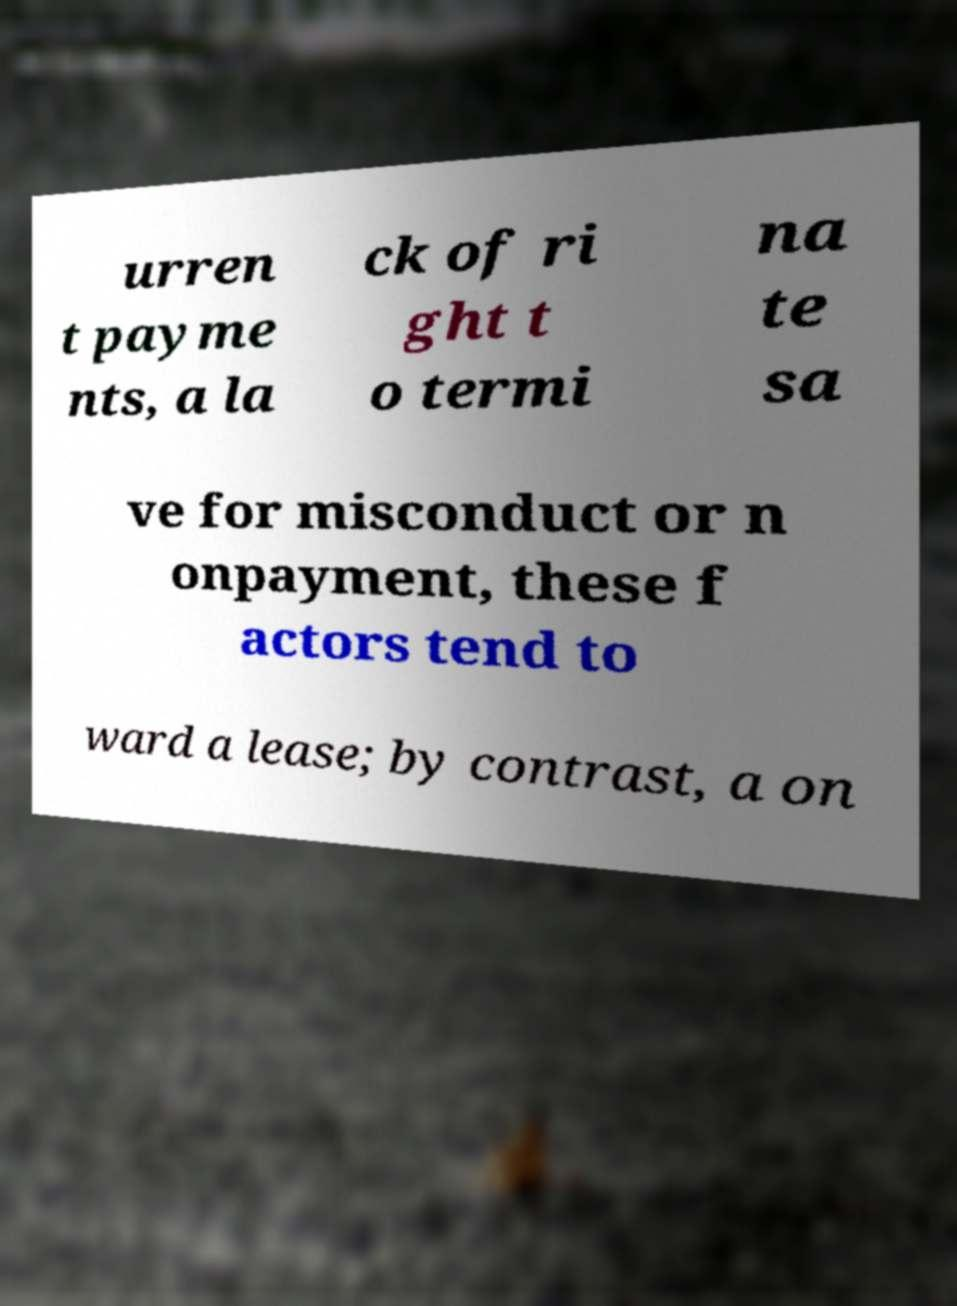Could you assist in decoding the text presented in this image and type it out clearly? urren t payme nts, a la ck of ri ght t o termi na te sa ve for misconduct or n onpayment, these f actors tend to ward a lease; by contrast, a on 